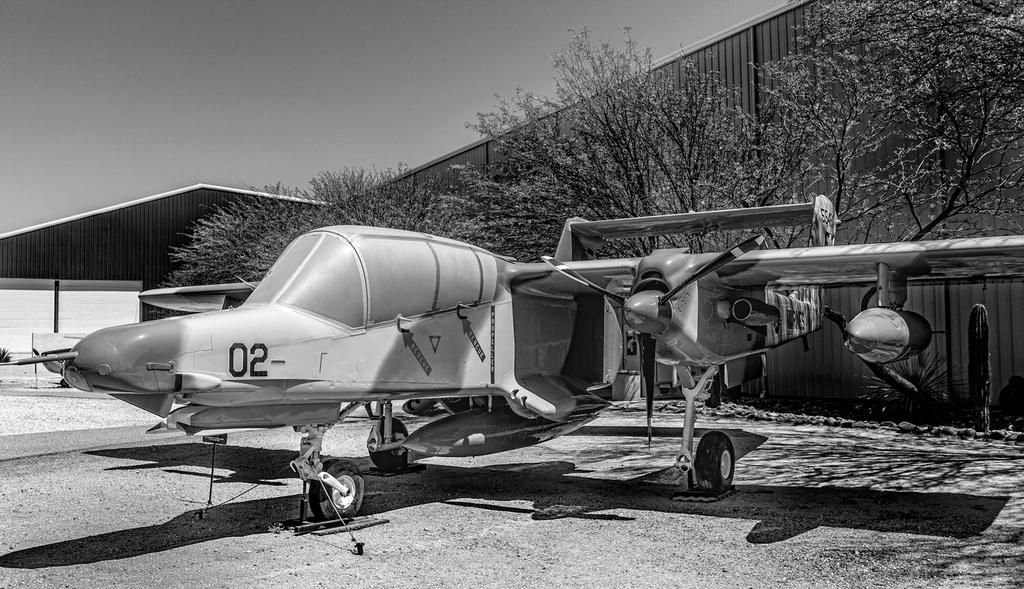<image>
Provide a brief description of the given image. An older style plane with the number 02 on the nose. 